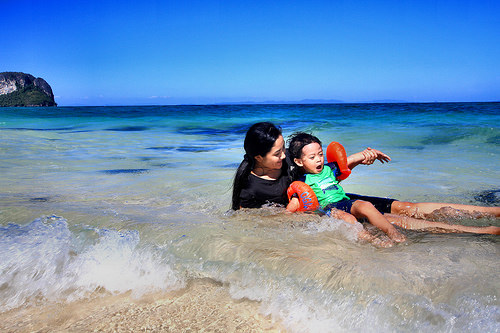<image>
Can you confirm if the baby is on the lady? Yes. Looking at the image, I can see the baby is positioned on top of the lady, with the lady providing support. 